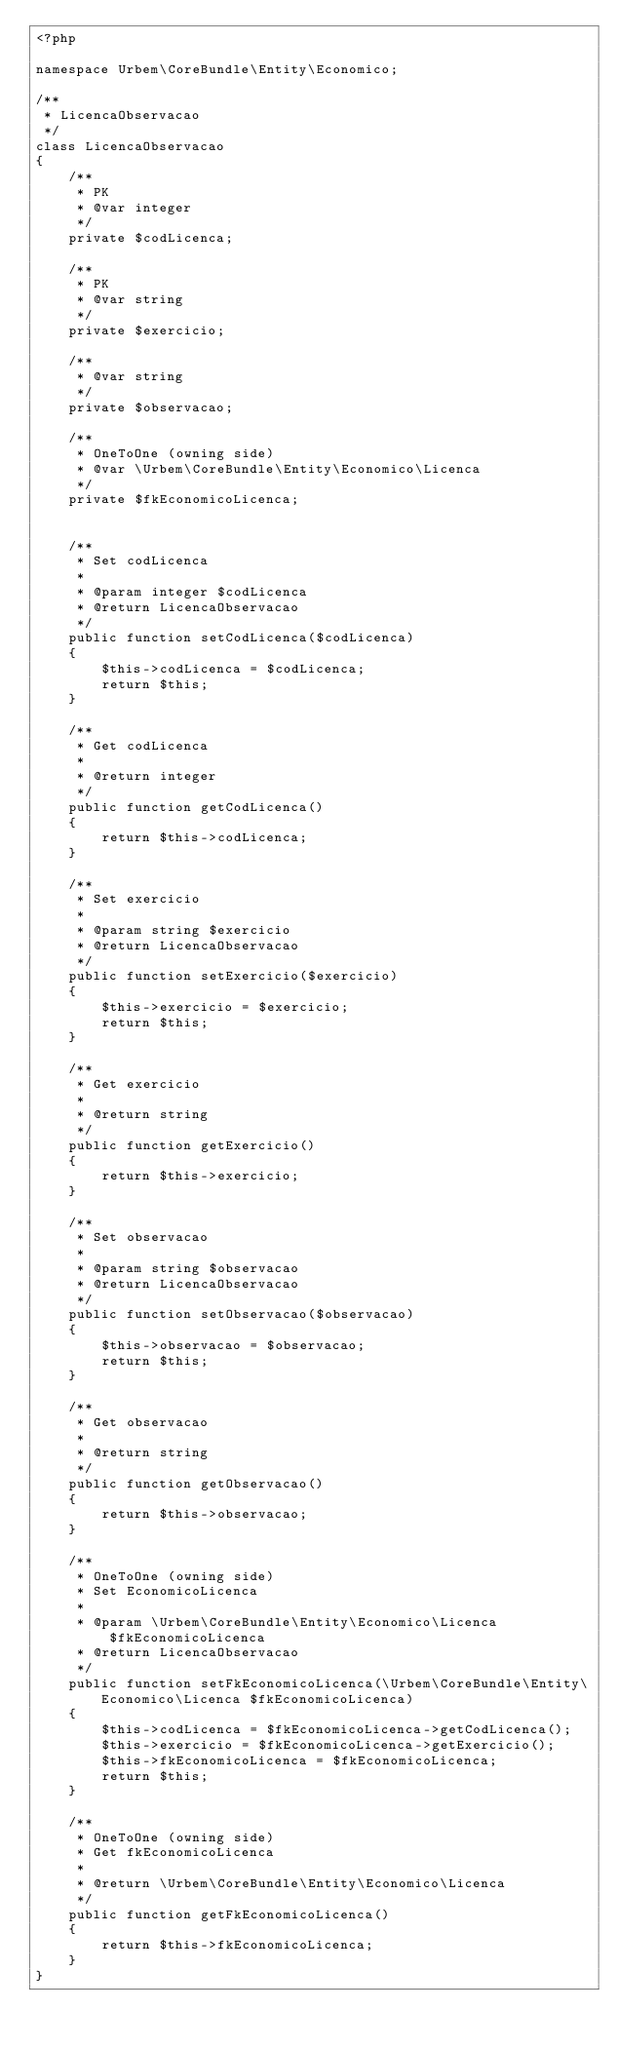<code> <loc_0><loc_0><loc_500><loc_500><_PHP_><?php
 
namespace Urbem\CoreBundle\Entity\Economico;

/**
 * LicencaObservacao
 */
class LicencaObservacao
{
    /**
     * PK
     * @var integer
     */
    private $codLicenca;

    /**
     * PK
     * @var string
     */
    private $exercicio;

    /**
     * @var string
     */
    private $observacao;

    /**
     * OneToOne (owning side)
     * @var \Urbem\CoreBundle\Entity\Economico\Licenca
     */
    private $fkEconomicoLicenca;


    /**
     * Set codLicenca
     *
     * @param integer $codLicenca
     * @return LicencaObservacao
     */
    public function setCodLicenca($codLicenca)
    {
        $this->codLicenca = $codLicenca;
        return $this;
    }

    /**
     * Get codLicenca
     *
     * @return integer
     */
    public function getCodLicenca()
    {
        return $this->codLicenca;
    }

    /**
     * Set exercicio
     *
     * @param string $exercicio
     * @return LicencaObservacao
     */
    public function setExercicio($exercicio)
    {
        $this->exercicio = $exercicio;
        return $this;
    }

    /**
     * Get exercicio
     *
     * @return string
     */
    public function getExercicio()
    {
        return $this->exercicio;
    }

    /**
     * Set observacao
     *
     * @param string $observacao
     * @return LicencaObservacao
     */
    public function setObservacao($observacao)
    {
        $this->observacao = $observacao;
        return $this;
    }

    /**
     * Get observacao
     *
     * @return string
     */
    public function getObservacao()
    {
        return $this->observacao;
    }

    /**
     * OneToOne (owning side)
     * Set EconomicoLicenca
     *
     * @param \Urbem\CoreBundle\Entity\Economico\Licenca $fkEconomicoLicenca
     * @return LicencaObservacao
     */
    public function setFkEconomicoLicenca(\Urbem\CoreBundle\Entity\Economico\Licenca $fkEconomicoLicenca)
    {
        $this->codLicenca = $fkEconomicoLicenca->getCodLicenca();
        $this->exercicio = $fkEconomicoLicenca->getExercicio();
        $this->fkEconomicoLicenca = $fkEconomicoLicenca;
        return $this;
    }

    /**
     * OneToOne (owning side)
     * Get fkEconomicoLicenca
     *
     * @return \Urbem\CoreBundle\Entity\Economico\Licenca
     */
    public function getFkEconomicoLicenca()
    {
        return $this->fkEconomicoLicenca;
    }
}
</code> 